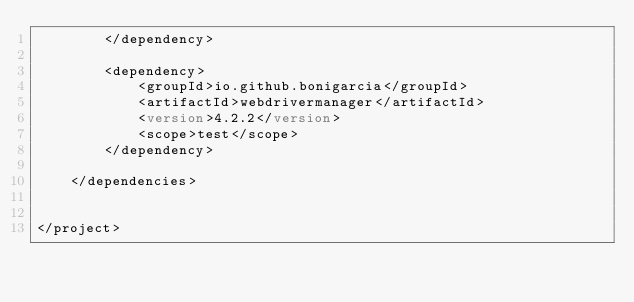Convert code to text. <code><loc_0><loc_0><loc_500><loc_500><_XML_>        </dependency>

        <dependency>
            <groupId>io.github.bonigarcia</groupId>
            <artifactId>webdrivermanager</artifactId>
            <version>4.2.2</version>
            <scope>test</scope>
        </dependency>

    </dependencies>


</project></code> 